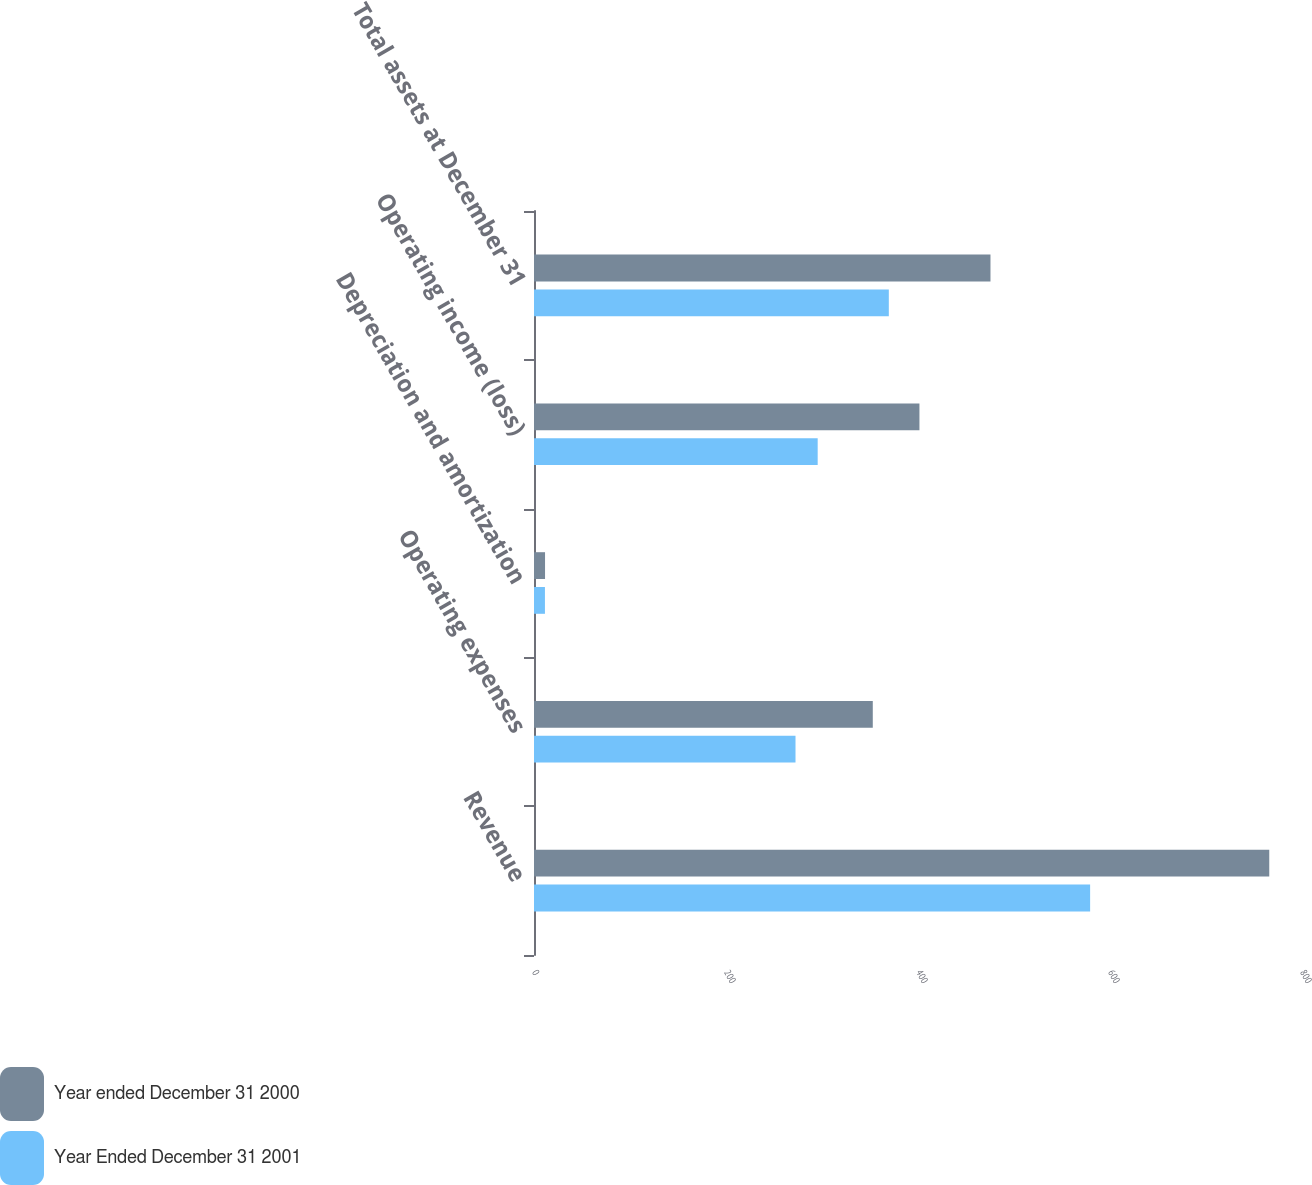Convert chart to OTSL. <chart><loc_0><loc_0><loc_500><loc_500><stacked_bar_chart><ecel><fcel>Revenue<fcel>Operating expenses<fcel>Depreciation and amortization<fcel>Operating income (loss)<fcel>Total assets at December 31<nl><fcel>Year ended December 31 2000<fcel>765.9<fcel>352.9<fcel>11.5<fcel>401.5<fcel>475.5<nl><fcel>Year Ended December 31 2001<fcel>579.3<fcel>272.4<fcel>11.4<fcel>295.5<fcel>369.6<nl></chart> 